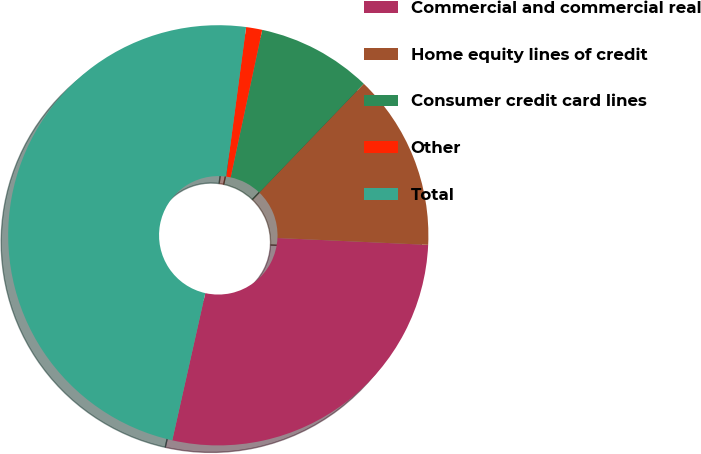Convert chart. <chart><loc_0><loc_0><loc_500><loc_500><pie_chart><fcel>Commercial and commercial real<fcel>Home equity lines of credit<fcel>Consumer credit card lines<fcel>Other<fcel>Total<nl><fcel>27.79%<fcel>13.55%<fcel>8.82%<fcel>1.24%<fcel>48.6%<nl></chart> 